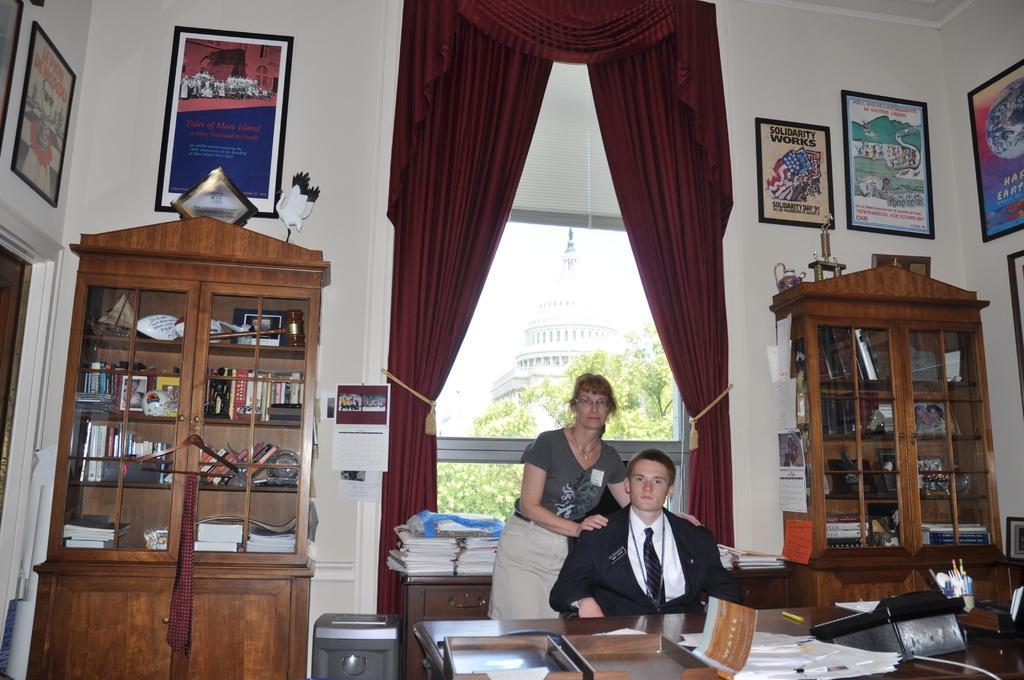Describe this image in one or two sentences. Here we can see a person sitting on a chair. There is a woman standing beside to this person. This is a wooden table. This is a window glass and this is a curtain. 